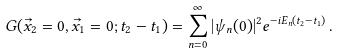Convert formula to latex. <formula><loc_0><loc_0><loc_500><loc_500>G ( \vec { x } _ { 2 } = 0 , \vec { x } _ { 1 } = 0 ; t _ { 2 } - t _ { 1 } ) = \sum _ { n = 0 } ^ { \infty } | \psi _ { n } ( 0 ) | ^ { 2 } e ^ { - i E _ { n } ( t _ { 2 } - t _ { 1 } ) } \, .</formula> 